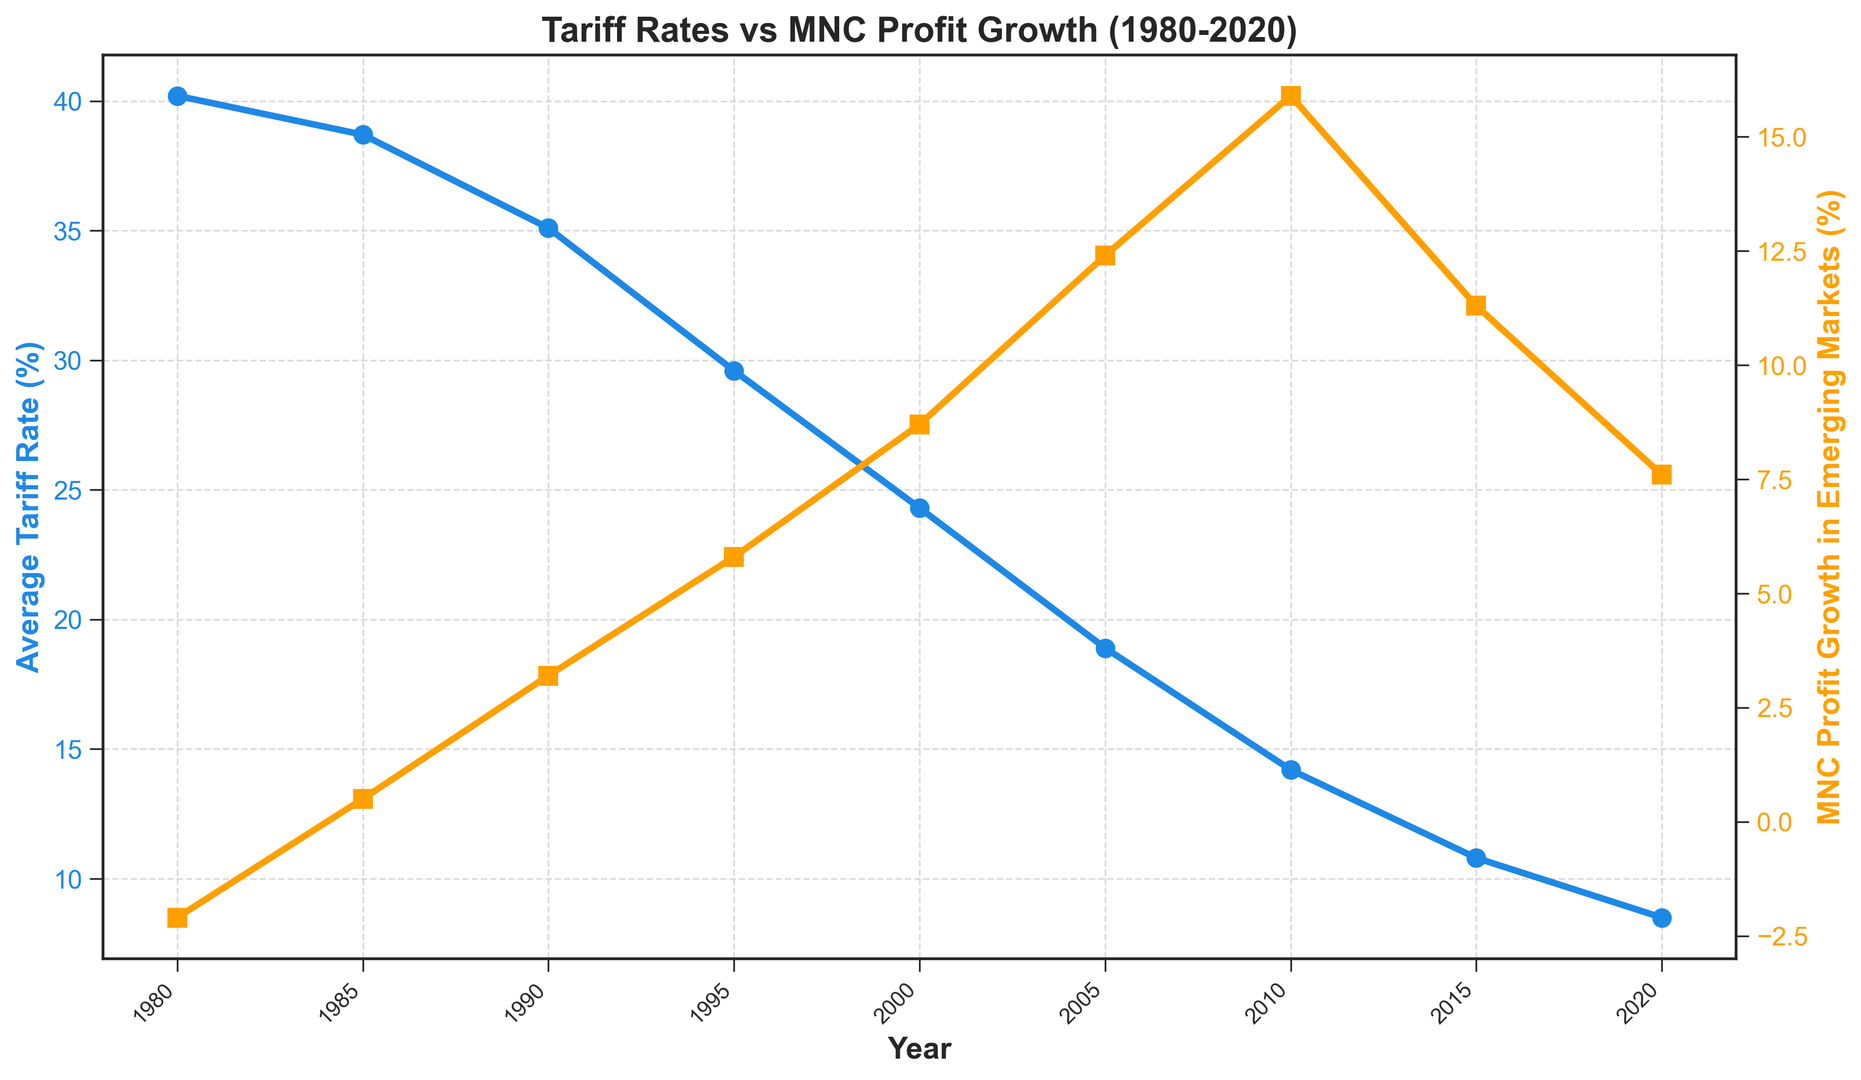What was the average tariff rate in 1990? Looking at the blue line on the chart, the average tariff rate for 1990 is marked.
Answer: 35.1% Has the MNC profit growth in emerging markets ever declined between 1980 and 2020? By observing the orange line, we can see the profit growth only decreased from 1980 to 1985.
Answer: Yes In which year did the average tariff rate drop below 20%? Checking the blue line, the first instance where the average tariff rate drops below 20% is around 2005.
Answer: 2005 By how much did the MNC profit growth in emerging markets increase between 2000 and 2005? The profit growth in 2000 is 8.7% and in 2005 is 12.4%, the difference is 12.4% - 8.7%.
Answer: 3.7% What is the relationship between tariff rates and MNC profit growth from 1980 to 2020? Observing the chart, as the tariff rates (blue line) decrease, the MNC profit growth (orange line) tends to increase.
Answer: Inversely proportional Which year shows the highest MNC profit growth in emerging markets and what was the rate? The peak of the orange line represents the highest profit growth, which is in 2010.
Answer: 2010, 15.9% By how many percentage points did the average tariff rate decrease from 1980 to 2020? The average tariff rate in 1980 was 40.2% and in 2020 it was 8.5%, the difference is 40.2% - 8.5%.
Answer: 31.7% When did the average tariff rate first fell below 30%? According to the blue line on the chart, the average tariff rate first dropped below 30% around 1995.
Answer: 1995 Identify the year with the largest single-year drop in tariff rates shown. Observing the blue line, the largest single-year drop seems to occur between 1995 and 2000.
Answer: 1995-2000 How much higher was the MNC profit growth in 2010 compared to 1985? The MNC profit growth in 2010 was 15.9% and in 1985 it was 0.5%, the difference is 15.9% - 0.5%.
Answer: 15.4% 